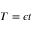Convert formula to latex. <formula><loc_0><loc_0><loc_500><loc_500>T = \epsilon t</formula> 